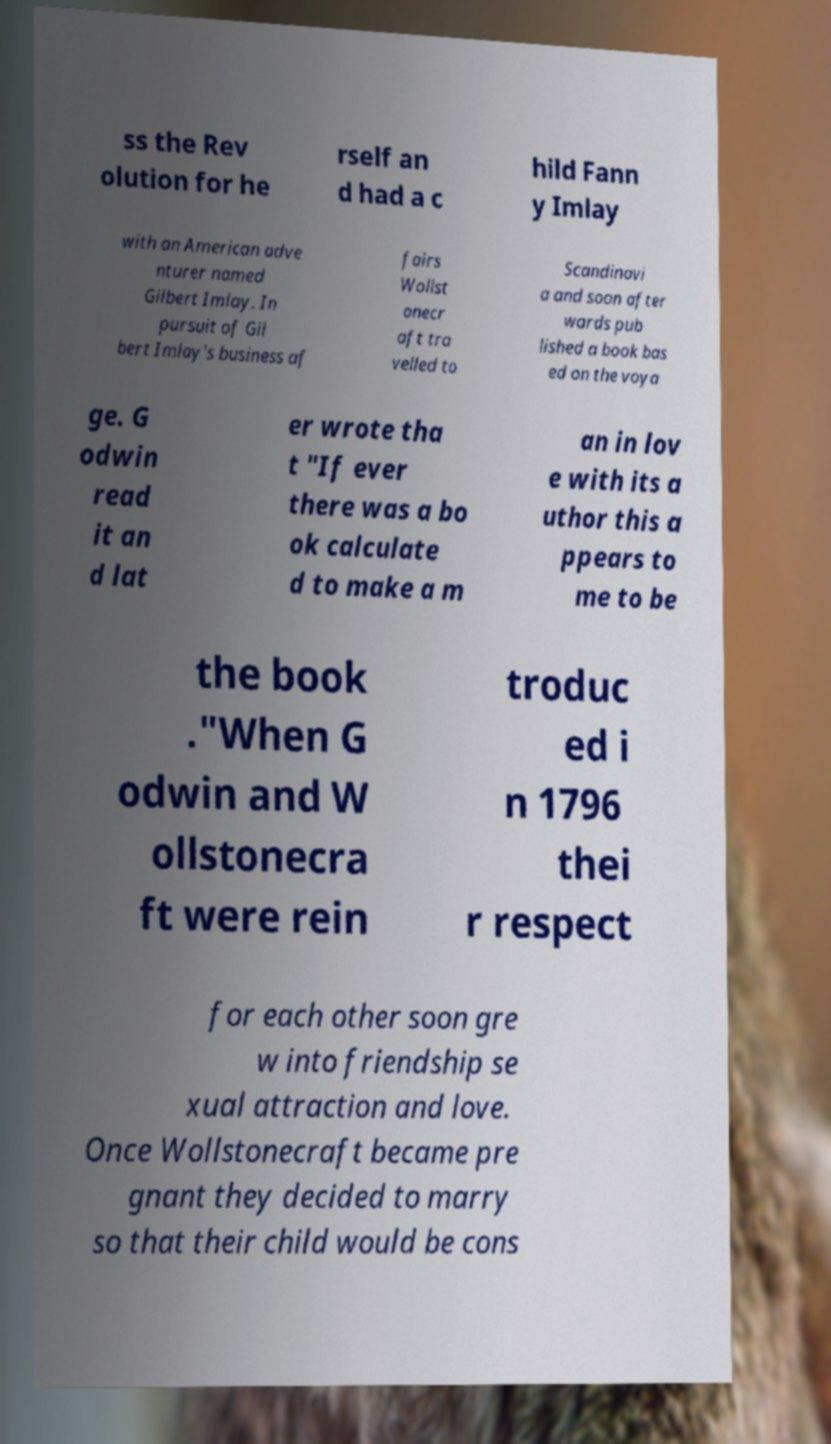There's text embedded in this image that I need extracted. Can you transcribe it verbatim? ss the Rev olution for he rself an d had a c hild Fann y Imlay with an American adve nturer named Gilbert Imlay. In pursuit of Gil bert Imlay's business af fairs Wollst onecr aft tra velled to Scandinavi a and soon after wards pub lished a book bas ed on the voya ge. G odwin read it an d lat er wrote tha t "If ever there was a bo ok calculate d to make a m an in lov e with its a uthor this a ppears to me to be the book ."When G odwin and W ollstonecra ft were rein troduc ed i n 1796 thei r respect for each other soon gre w into friendship se xual attraction and love. Once Wollstonecraft became pre gnant they decided to marry so that their child would be cons 